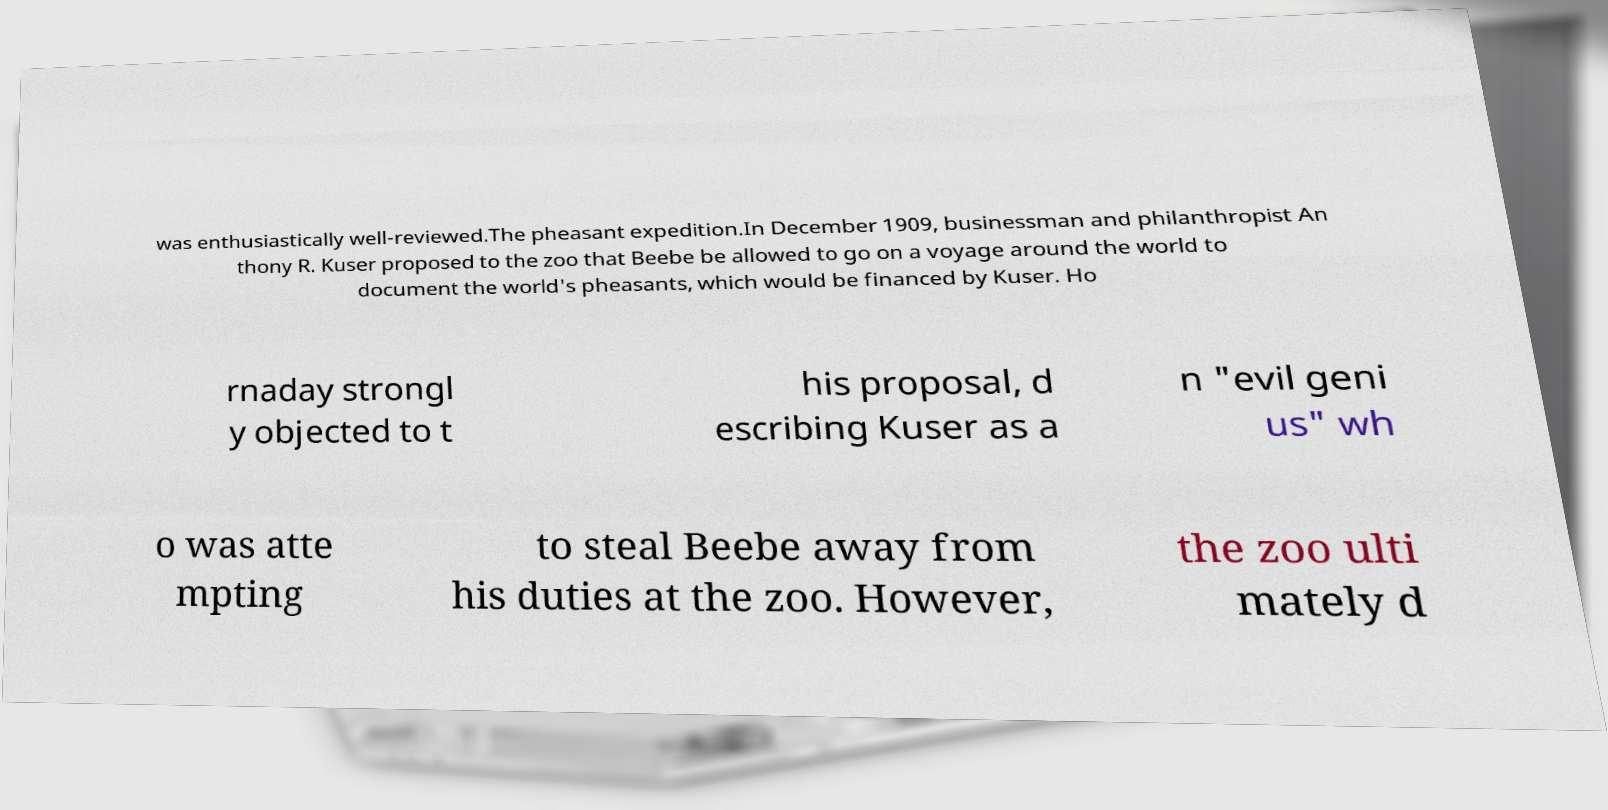Please read and relay the text visible in this image. What does it say? was enthusiastically well-reviewed.The pheasant expedition.In December 1909, businessman and philanthropist An thony R. Kuser proposed to the zoo that Beebe be allowed to go on a voyage around the world to document the world's pheasants, which would be financed by Kuser. Ho rnaday strongl y objected to t his proposal, d escribing Kuser as a n "evil geni us" wh o was atte mpting to steal Beebe away from his duties at the zoo. However, the zoo ulti mately d 